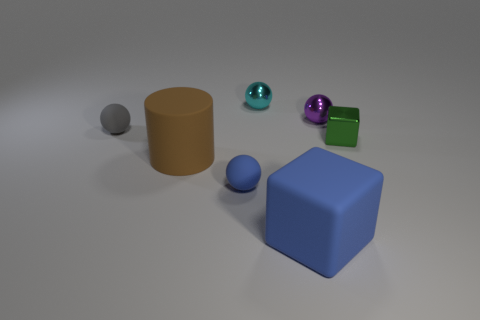Is there any other thing that has the same shape as the brown rubber object?
Your response must be concise. No. Are there any other things of the same color as the small cube?
Ensure brevity in your answer.  No. Does the cyan sphere have the same material as the small thing that is on the left side of the big brown rubber cylinder?
Ensure brevity in your answer.  No. There is a small cyan thing that is the same shape as the small blue rubber thing; what material is it?
Provide a short and direct response. Metal. Is there anything else that is the same material as the cyan sphere?
Offer a very short reply. Yes. Is the material of the blue thing left of the big block the same as the cyan object that is to the right of the blue ball?
Offer a very short reply. No. There is a tiny rubber object that is in front of the cube that is on the right side of the blue object that is on the right side of the tiny blue thing; what is its color?
Make the answer very short. Blue. How many other things are there of the same shape as the small cyan thing?
Give a very brief answer. 3. Does the tiny cube have the same color as the cylinder?
Offer a terse response. No. How many objects are either large metallic spheres or rubber balls left of the large brown matte thing?
Your answer should be very brief. 1. 